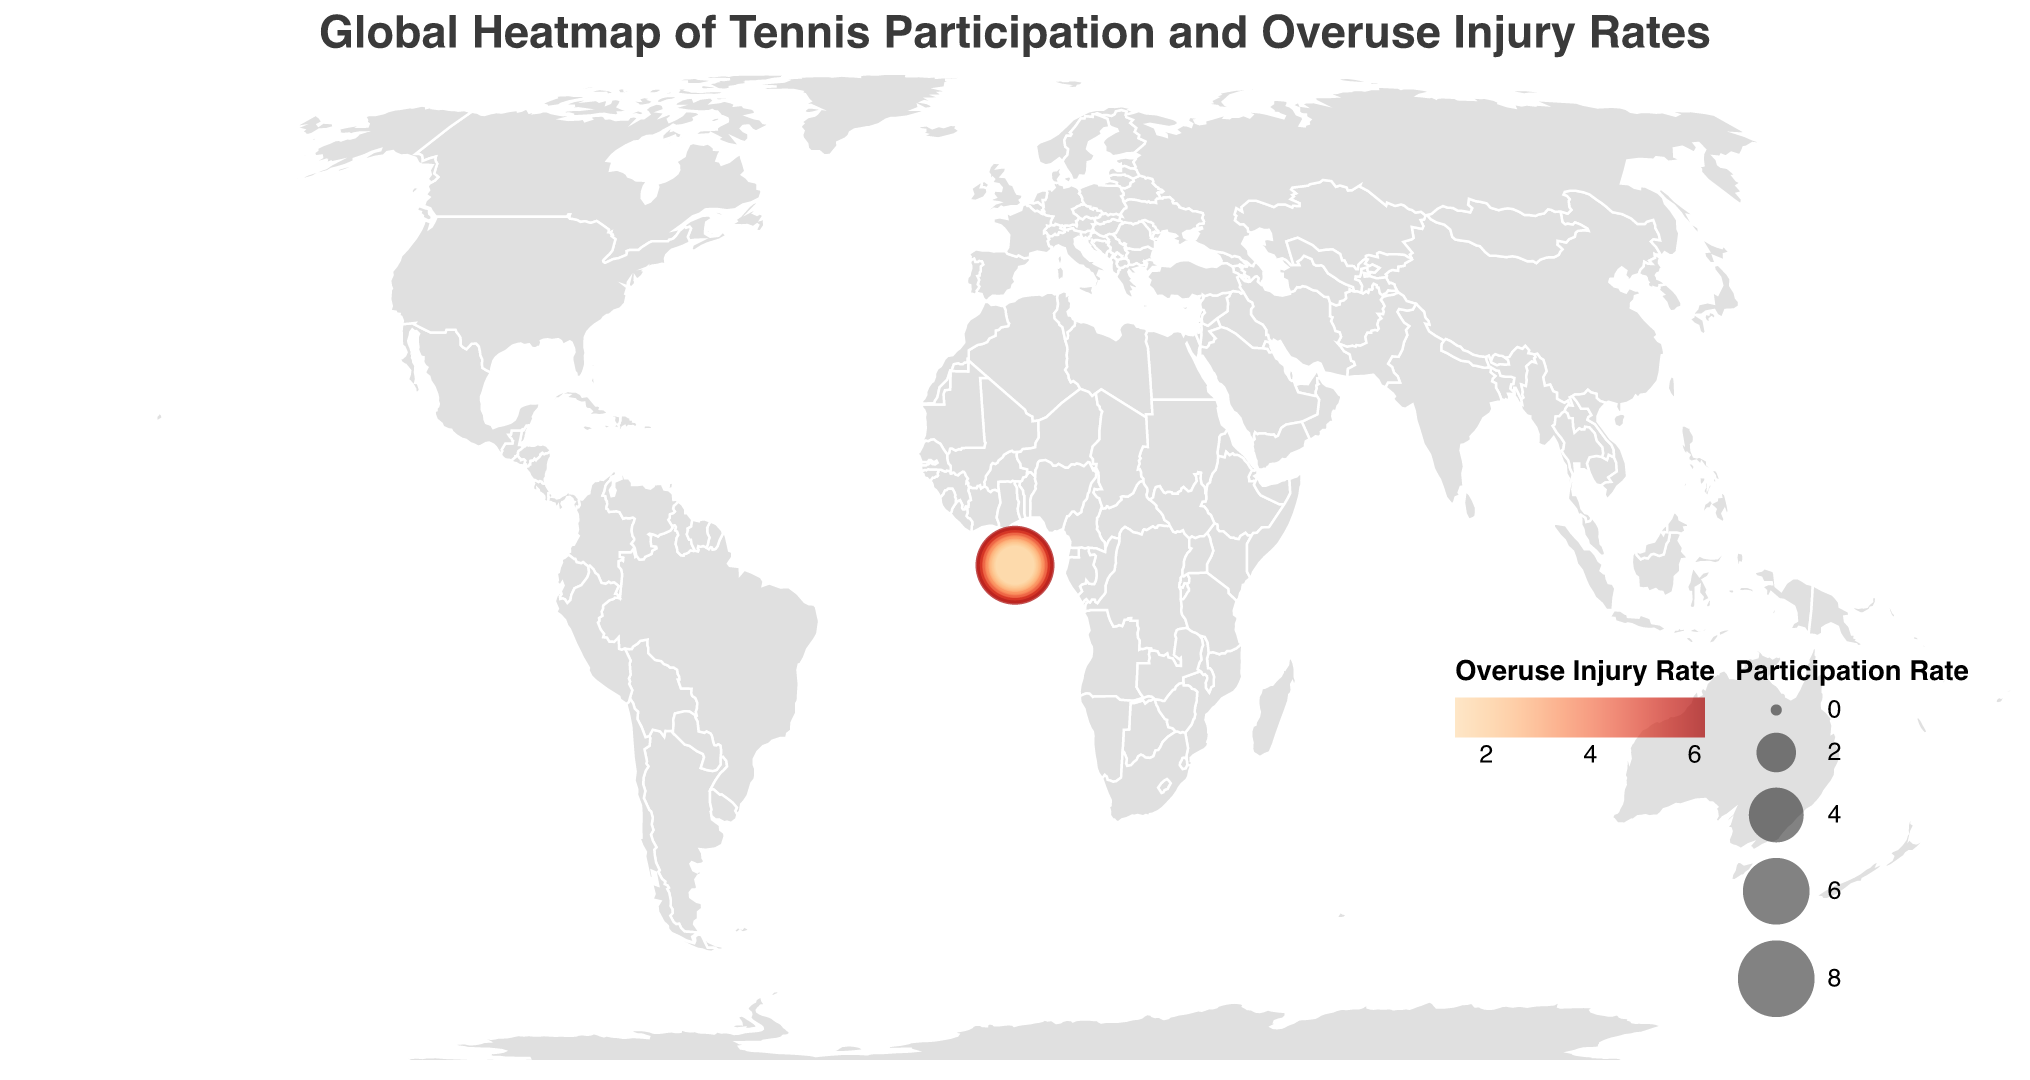What's the title of the figure? The title is usually prominently displayed at the top of the figure. It reads "Global Heatmap of Tennis Participation and Overuse Injury Rates"
Answer: "Global Heatmap of Tennis Participation and Overuse Injury Rates" What are the two variables represented in the heatmap? The color of the circles represents the overuse injury rates, and the size of the circles represents the participation rates in tennis.
Answer: Participation Rate and Overuse Injury Rate Which country has the highest tennis participation rate? By looking at the largest circle in the heatmap, we see that the United States has the largest circle, indicating the highest participation rate.
Answer: United States Which country has the highest overuse injury rate? By looking at the darkest colored circle, we see that the United States has the darkest circle, indicating the highest overuse injury rate.
Answer: United States Compare the participation rates of Spain and France. Which is higher? Spain has a participation rate of 7.9, while France has a participation rate of 6.7. 7.9 is greater than 6.7, so Spain's participation rate is higher.
Answer: Spain Compare the overuse injury rates of Australia and the United Kingdom. Which is higher? Australia has an overuse injury rate of 5.1, while the United Kingdom has an overuse injury rate of 4.1. 5.1 is greater than 4.1, so Australia's overuse injury rate is higher.
Answer: Australia What is the median overuse injury rate among all countries listed? Arrange the overuse injury rates in ascending order and find the middle value. Ordered list: 1.4, 1.6, 1.7, 1.9, 2.0, 2.1, 2.4, 2.5, 2.7, 2.8, 3.2, 3.4, 3.5, 3.7, 4.1, 4.3, 4.9, 5.1, 5.8, 6.2. The middle values are 3.2 and 3.4, so the median is the average of these two values: (3.2 + 3.4) / 2 = 3.3.
Answer: 3.3 What is the range of participation rates shown in the heatmap? The participation rate ranges from the minimum to the maximum values in the dataset. The minimum participation rate is 1.9 (Czech Republic), and the maximum participation rate is 8.5 (United States). The range is 8.5 - 1.9 = 6.6.
Answer: 6.6 Identify the country with the lowest overuse injury rate and its corresponding participation rate. The country with the lightest colored circle (indicating the lowest overuse injury rate) is the Czech Republic with an overuse injury rate of 1.4 and a participation rate of 1.9.
Answer: Czech Republic, 1.9 